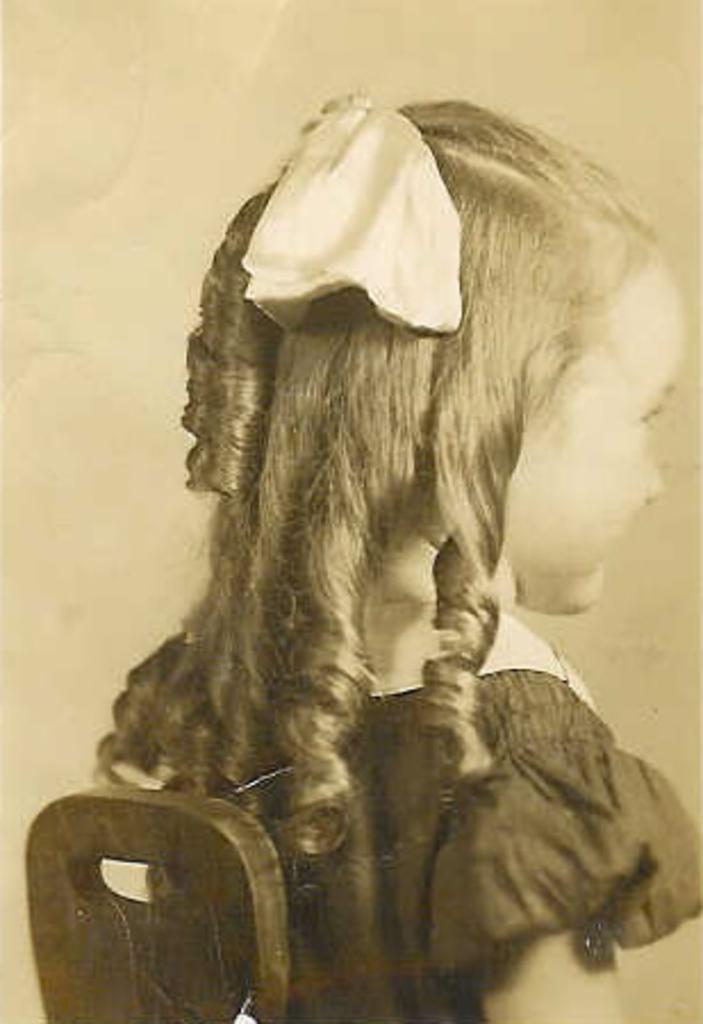Can you describe this image briefly? In this image, we can see a kid wearing clothes. 